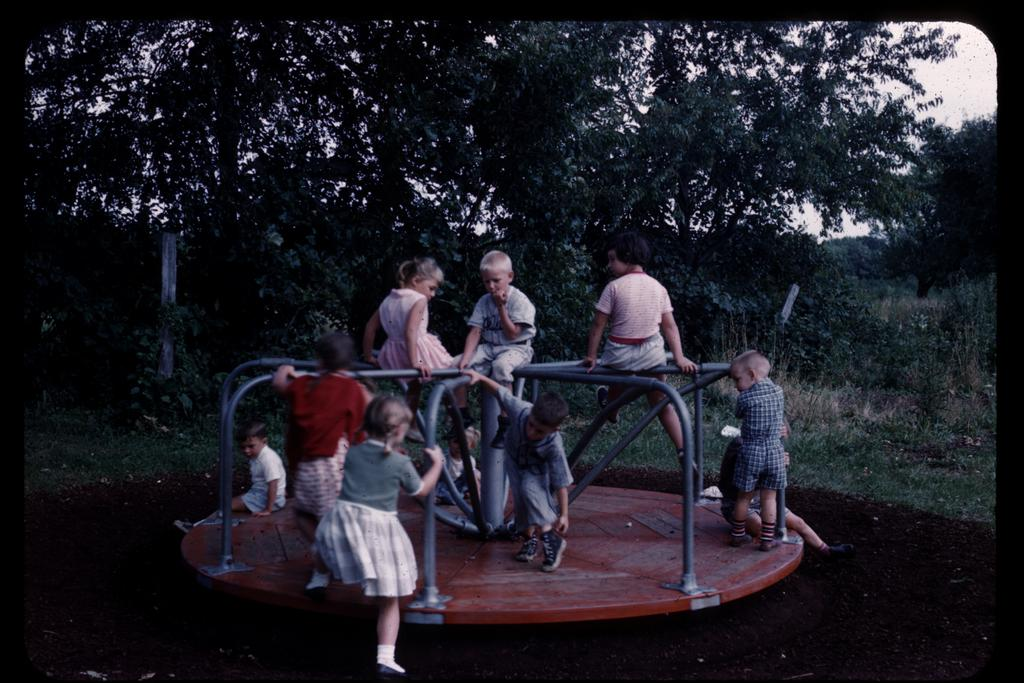What is the main subject in the foreground of the image? There are kids in the foreground of the image. What are the kids doing in the image? The kids are sitting and standing on circular park equipment. What can be seen in the background of the image? There are trees, poles, and the sky visible in the background of the image. What type of suit can be seen hanging on the pole in the image? There is no suit present in the image; the poles are part of the park equipment or possibly for hanging swings. Is there a hospital visible in the image? There is no hospital present in the image; it features kids playing on park equipment with trees, poles, and the sky in the background. 